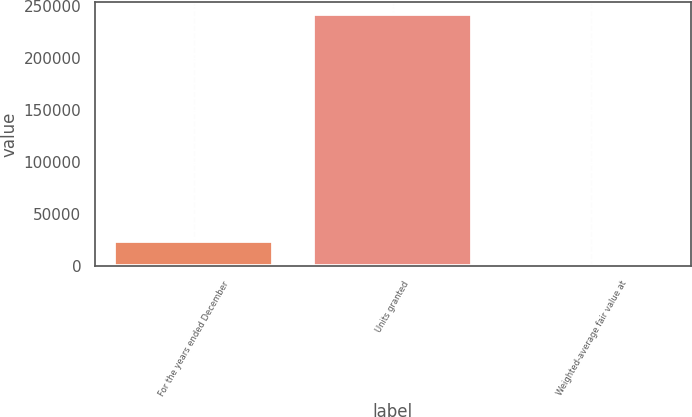Convert chart to OTSL. <chart><loc_0><loc_0><loc_500><loc_500><bar_chart><fcel>For the years ended December<fcel>Units granted<fcel>Weighted-average fair value at<nl><fcel>24240.2<fcel>241887<fcel>57.21<nl></chart> 